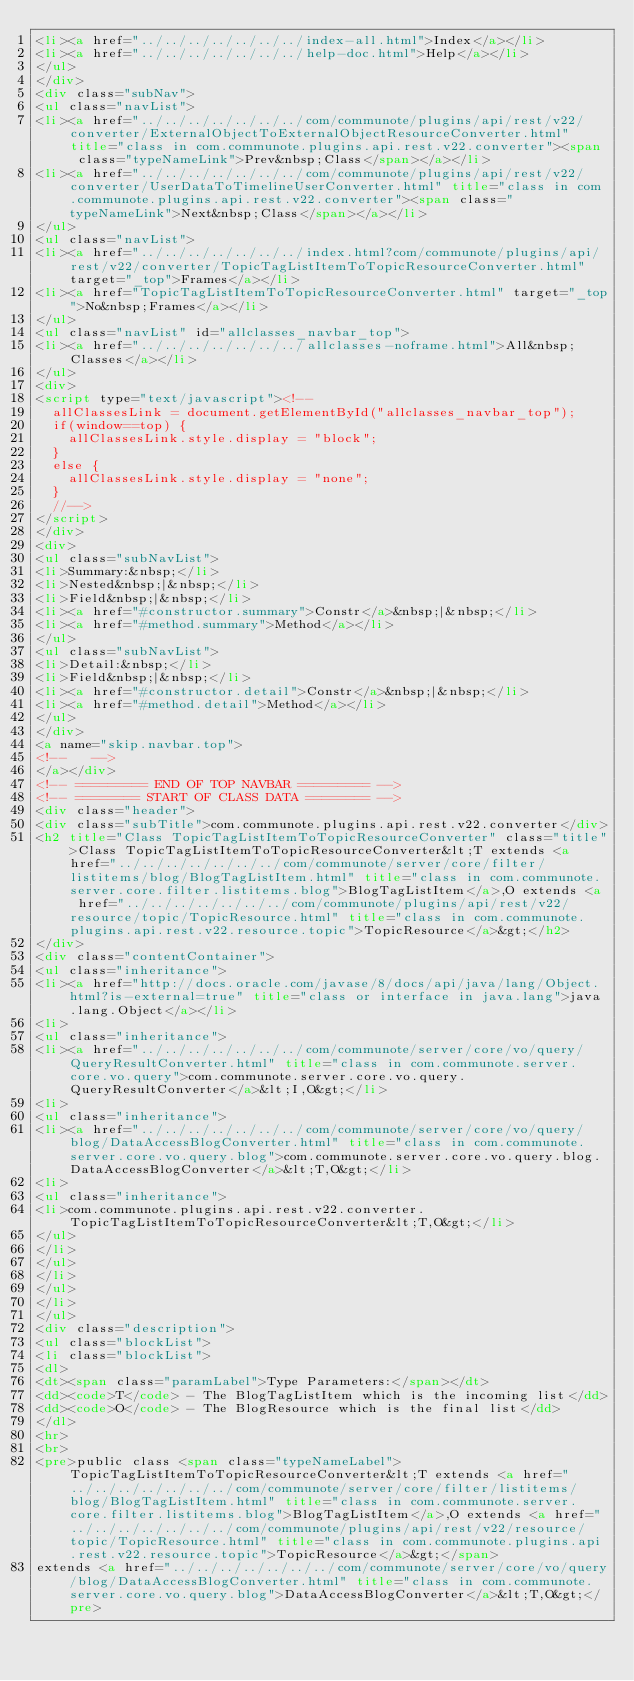Convert code to text. <code><loc_0><loc_0><loc_500><loc_500><_HTML_><li><a href="../../../../../../../index-all.html">Index</a></li>
<li><a href="../../../../../../../help-doc.html">Help</a></li>
</ul>
</div>
<div class="subNav">
<ul class="navList">
<li><a href="../../../../../../../com/communote/plugins/api/rest/v22/converter/ExternalObjectToExternalObjectResourceConverter.html" title="class in com.communote.plugins.api.rest.v22.converter"><span class="typeNameLink">Prev&nbsp;Class</span></a></li>
<li><a href="../../../../../../../com/communote/plugins/api/rest/v22/converter/UserDataToTimelineUserConverter.html" title="class in com.communote.plugins.api.rest.v22.converter"><span class="typeNameLink">Next&nbsp;Class</span></a></li>
</ul>
<ul class="navList">
<li><a href="../../../../../../../index.html?com/communote/plugins/api/rest/v22/converter/TopicTagListItemToTopicResourceConverter.html" target="_top">Frames</a></li>
<li><a href="TopicTagListItemToTopicResourceConverter.html" target="_top">No&nbsp;Frames</a></li>
</ul>
<ul class="navList" id="allclasses_navbar_top">
<li><a href="../../../../../../../allclasses-noframe.html">All&nbsp;Classes</a></li>
</ul>
<div>
<script type="text/javascript"><!--
  allClassesLink = document.getElementById("allclasses_navbar_top");
  if(window==top) {
    allClassesLink.style.display = "block";
  }
  else {
    allClassesLink.style.display = "none";
  }
  //-->
</script>
</div>
<div>
<ul class="subNavList">
<li>Summary:&nbsp;</li>
<li>Nested&nbsp;|&nbsp;</li>
<li>Field&nbsp;|&nbsp;</li>
<li><a href="#constructor.summary">Constr</a>&nbsp;|&nbsp;</li>
<li><a href="#method.summary">Method</a></li>
</ul>
<ul class="subNavList">
<li>Detail:&nbsp;</li>
<li>Field&nbsp;|&nbsp;</li>
<li><a href="#constructor.detail">Constr</a>&nbsp;|&nbsp;</li>
<li><a href="#method.detail">Method</a></li>
</ul>
</div>
<a name="skip.navbar.top">
<!--   -->
</a></div>
<!-- ========= END OF TOP NAVBAR ========= -->
<!-- ======== START OF CLASS DATA ======== -->
<div class="header">
<div class="subTitle">com.communote.plugins.api.rest.v22.converter</div>
<h2 title="Class TopicTagListItemToTopicResourceConverter" class="title">Class TopicTagListItemToTopicResourceConverter&lt;T extends <a href="../../../../../../../com/communote/server/core/filter/listitems/blog/BlogTagListItem.html" title="class in com.communote.server.core.filter.listitems.blog">BlogTagListItem</a>,O extends <a href="../../../../../../../com/communote/plugins/api/rest/v22/resource/topic/TopicResource.html" title="class in com.communote.plugins.api.rest.v22.resource.topic">TopicResource</a>&gt;</h2>
</div>
<div class="contentContainer">
<ul class="inheritance">
<li><a href="http://docs.oracle.com/javase/8/docs/api/java/lang/Object.html?is-external=true" title="class or interface in java.lang">java.lang.Object</a></li>
<li>
<ul class="inheritance">
<li><a href="../../../../../../../com/communote/server/core/vo/query/QueryResultConverter.html" title="class in com.communote.server.core.vo.query">com.communote.server.core.vo.query.QueryResultConverter</a>&lt;I,O&gt;</li>
<li>
<ul class="inheritance">
<li><a href="../../../../../../../com/communote/server/core/vo/query/blog/DataAccessBlogConverter.html" title="class in com.communote.server.core.vo.query.blog">com.communote.server.core.vo.query.blog.DataAccessBlogConverter</a>&lt;T,O&gt;</li>
<li>
<ul class="inheritance">
<li>com.communote.plugins.api.rest.v22.converter.TopicTagListItemToTopicResourceConverter&lt;T,O&gt;</li>
</ul>
</li>
</ul>
</li>
</ul>
</li>
</ul>
<div class="description">
<ul class="blockList">
<li class="blockList">
<dl>
<dt><span class="paramLabel">Type Parameters:</span></dt>
<dd><code>T</code> - The BlogTagListItem which is the incoming list</dd>
<dd><code>O</code> - The BlogResource which is the final list</dd>
</dl>
<hr>
<br>
<pre>public class <span class="typeNameLabel">TopicTagListItemToTopicResourceConverter&lt;T extends <a href="../../../../../../../com/communote/server/core/filter/listitems/blog/BlogTagListItem.html" title="class in com.communote.server.core.filter.listitems.blog">BlogTagListItem</a>,O extends <a href="../../../../../../../com/communote/plugins/api/rest/v22/resource/topic/TopicResource.html" title="class in com.communote.plugins.api.rest.v22.resource.topic">TopicResource</a>&gt;</span>
extends <a href="../../../../../../../com/communote/server/core/vo/query/blog/DataAccessBlogConverter.html" title="class in com.communote.server.core.vo.query.blog">DataAccessBlogConverter</a>&lt;T,O&gt;</pre></code> 